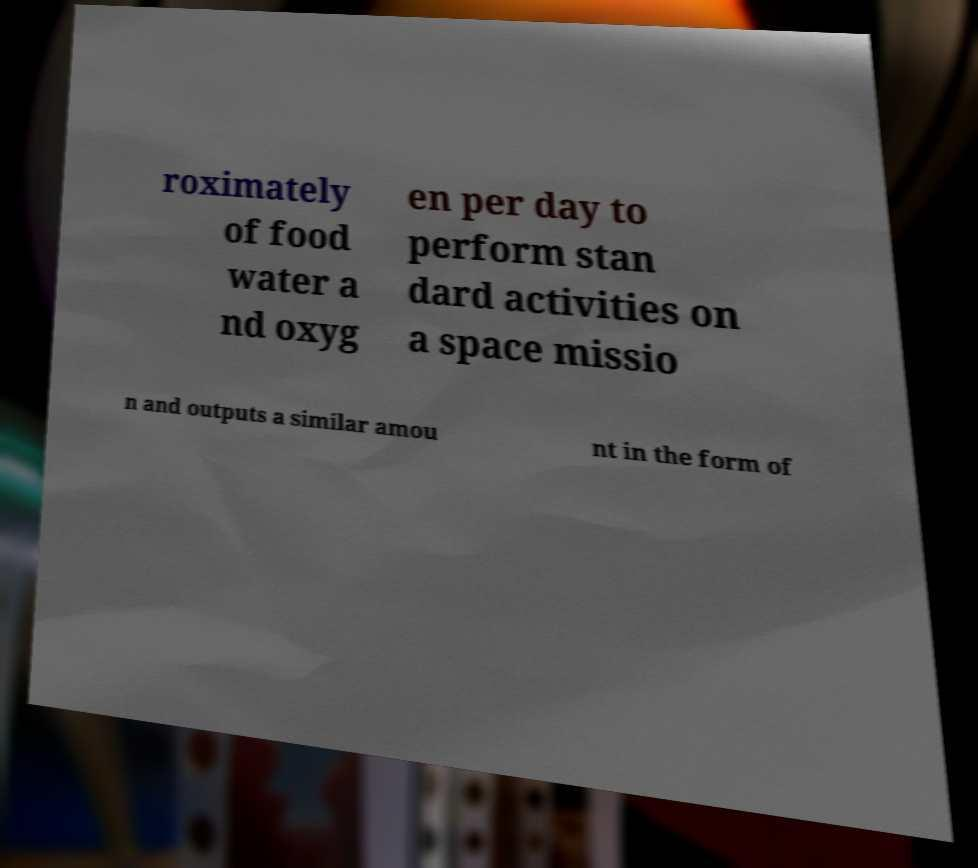Could you assist in decoding the text presented in this image and type it out clearly? roximately of food water a nd oxyg en per day to perform stan dard activities on a space missio n and outputs a similar amou nt in the form of 